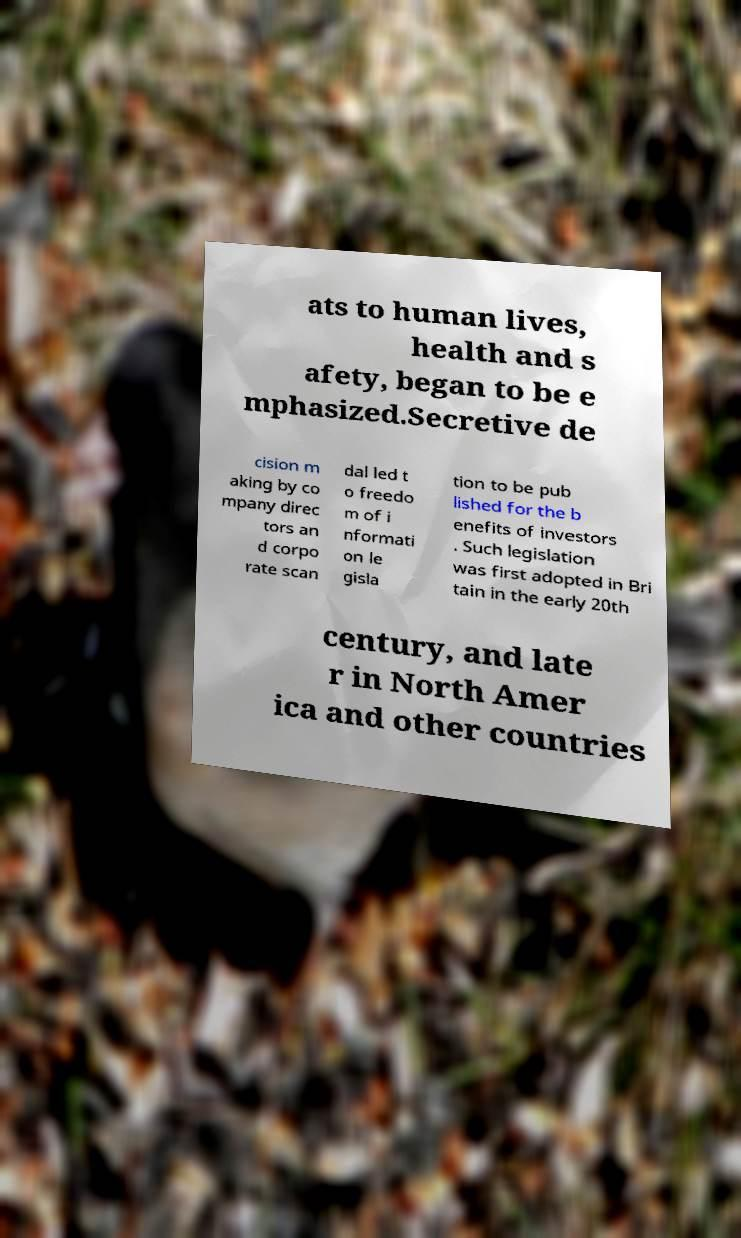There's text embedded in this image that I need extracted. Can you transcribe it verbatim? ats to human lives, health and s afety, began to be e mphasized.Secretive de cision m aking by co mpany direc tors an d corpo rate scan dal led t o freedo m of i nformati on le gisla tion to be pub lished for the b enefits of investors . Such legislation was first adopted in Bri tain in the early 20th century, and late r in North Amer ica and other countries 